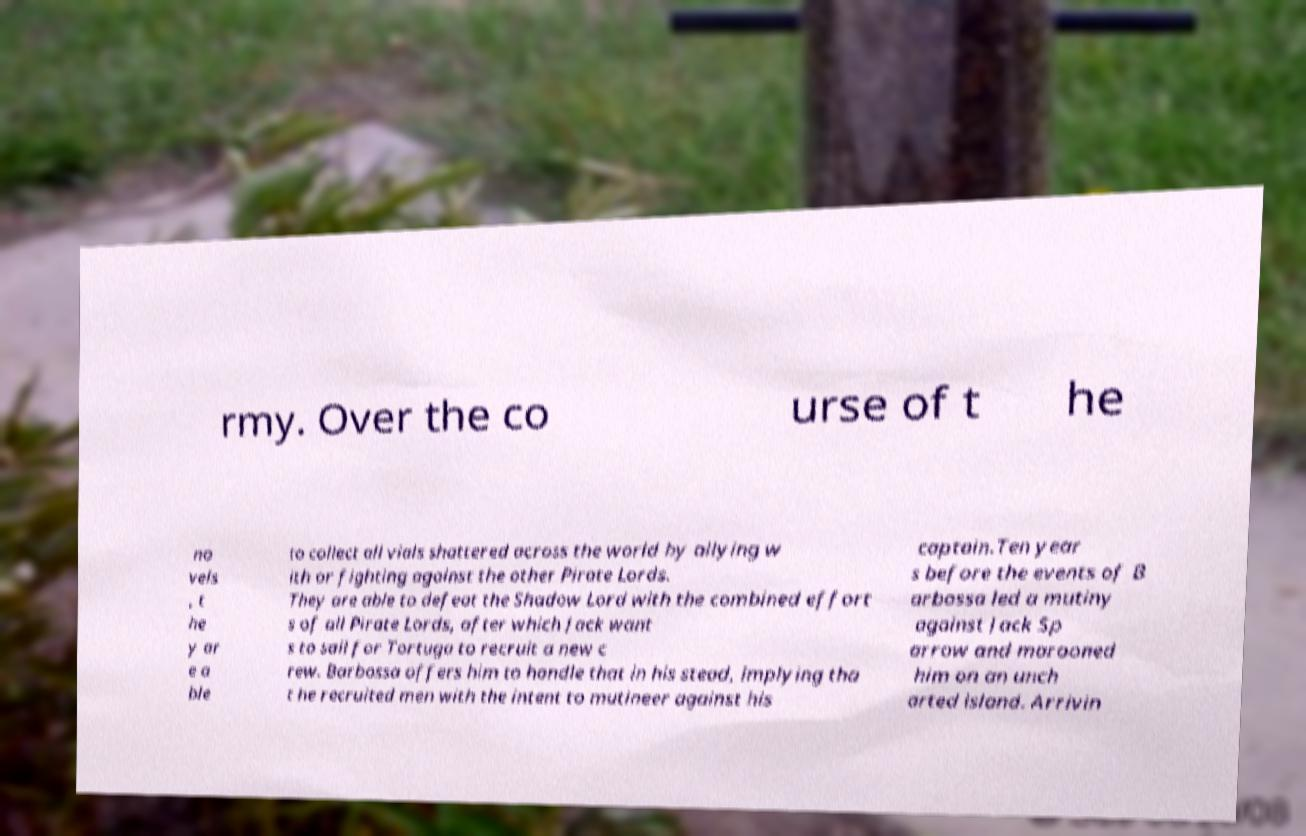Can you read and provide the text displayed in the image?This photo seems to have some interesting text. Can you extract and type it out for me? rmy. Over the co urse of t he no vels , t he y ar e a ble to collect all vials shattered across the world by allying w ith or fighting against the other Pirate Lords. They are able to defeat the Shadow Lord with the combined effort s of all Pirate Lords, after which Jack want s to sail for Tortuga to recruit a new c rew. Barbossa offers him to handle that in his stead, implying tha t he recruited men with the intent to mutineer against his captain.Ten year s before the events of B arbossa led a mutiny against Jack Sp arrow and marooned him on an unch arted island. Arrivin 